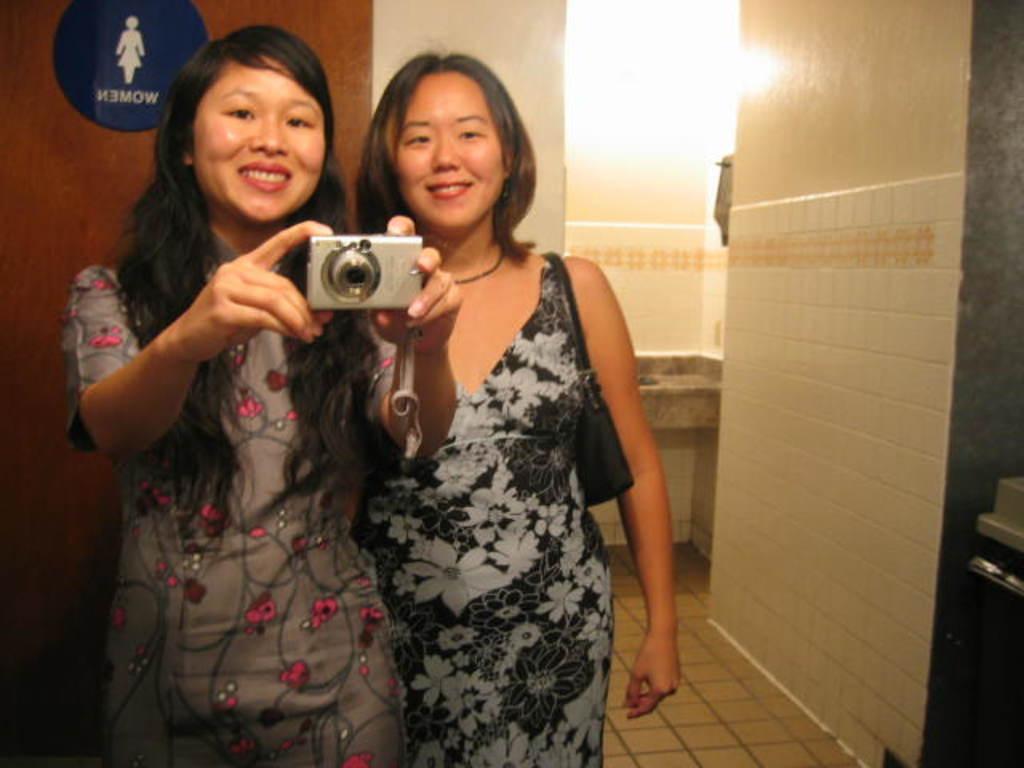In one or two sentences, can you explain what this image depicts? there is a room in room there are two women are present and two women are wearing the frock and one woman she is holding the camera and another woman she is holding the bag and behind the woman there is big bag 